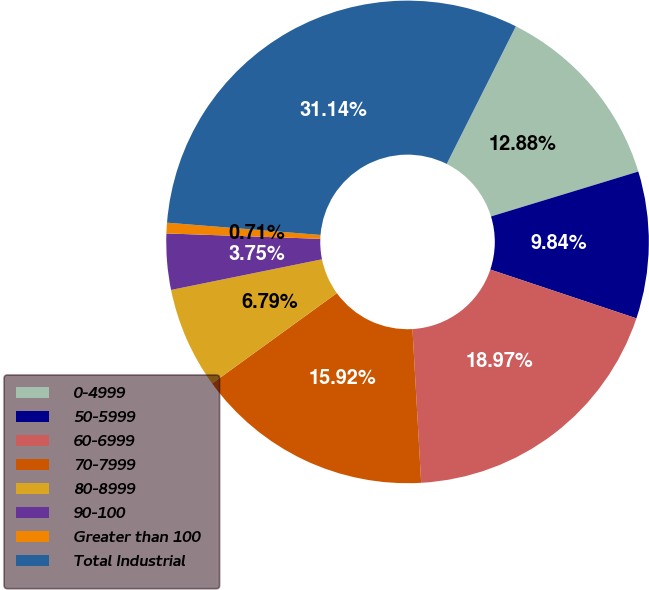<chart> <loc_0><loc_0><loc_500><loc_500><pie_chart><fcel>0-4999<fcel>50-5999<fcel>60-6999<fcel>70-7999<fcel>80-8999<fcel>90-100<fcel>Greater than 100<fcel>Total Industrial<nl><fcel>12.88%<fcel>9.84%<fcel>18.97%<fcel>15.92%<fcel>6.79%<fcel>3.75%<fcel>0.71%<fcel>31.14%<nl></chart> 